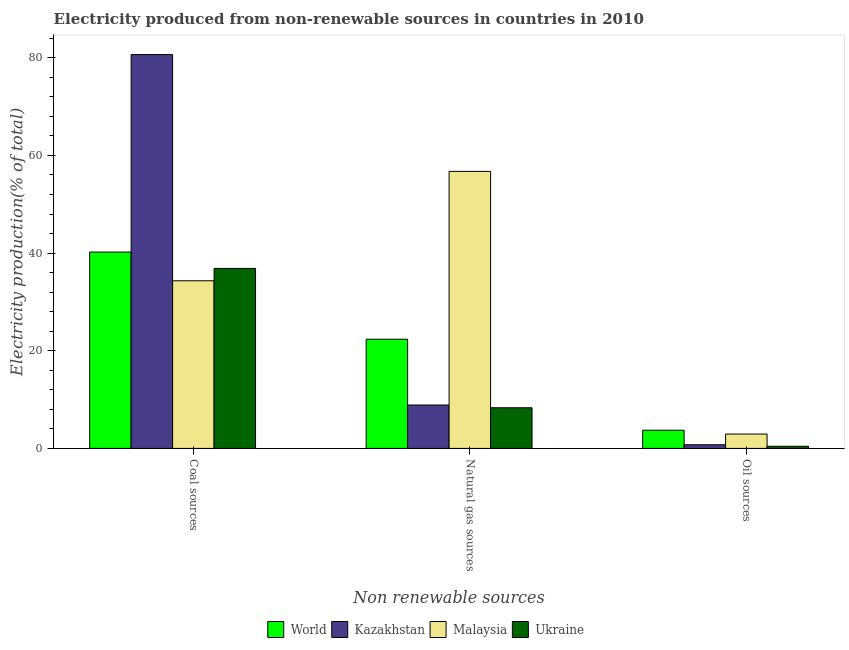How many bars are there on the 3rd tick from the right?
Your response must be concise. 4. What is the label of the 2nd group of bars from the left?
Ensure brevity in your answer.  Natural gas sources. What is the percentage of electricity produced by oil sources in Malaysia?
Provide a succinct answer. 2.94. Across all countries, what is the maximum percentage of electricity produced by natural gas?
Your response must be concise. 56.73. Across all countries, what is the minimum percentage of electricity produced by natural gas?
Offer a very short reply. 8.33. In which country was the percentage of electricity produced by natural gas maximum?
Your response must be concise. Malaysia. In which country was the percentage of electricity produced by natural gas minimum?
Offer a very short reply. Ukraine. What is the total percentage of electricity produced by coal in the graph?
Your answer should be compact. 192.06. What is the difference between the percentage of electricity produced by oil sources in Ukraine and that in Malaysia?
Your answer should be compact. -2.51. What is the difference between the percentage of electricity produced by natural gas in Malaysia and the percentage of electricity produced by coal in World?
Offer a very short reply. 16.52. What is the average percentage of electricity produced by natural gas per country?
Make the answer very short. 24.08. What is the difference between the percentage of electricity produced by oil sources and percentage of electricity produced by natural gas in Malaysia?
Your response must be concise. -53.79. In how many countries, is the percentage of electricity produced by oil sources greater than 36 %?
Make the answer very short. 0. What is the ratio of the percentage of electricity produced by natural gas in Malaysia to that in Ukraine?
Keep it short and to the point. 6.81. What is the difference between the highest and the second highest percentage of electricity produced by oil sources?
Your answer should be compact. 0.79. What is the difference between the highest and the lowest percentage of electricity produced by oil sources?
Your response must be concise. 3.29. Is the sum of the percentage of electricity produced by coal in World and Ukraine greater than the maximum percentage of electricity produced by natural gas across all countries?
Provide a short and direct response. Yes. What does the 1st bar from the left in Natural gas sources represents?
Provide a short and direct response. World. What does the 1st bar from the right in Natural gas sources represents?
Your answer should be compact. Ukraine. Are all the bars in the graph horizontal?
Offer a terse response. No. How many countries are there in the graph?
Your response must be concise. 4. What is the difference between two consecutive major ticks on the Y-axis?
Offer a very short reply. 20. Does the graph contain grids?
Your answer should be compact. No. Where does the legend appear in the graph?
Provide a succinct answer. Bottom center. How are the legend labels stacked?
Make the answer very short. Horizontal. What is the title of the graph?
Your answer should be very brief. Electricity produced from non-renewable sources in countries in 2010. What is the label or title of the X-axis?
Offer a very short reply. Non renewable sources. What is the Electricity production(% of total) of World in Coal sources?
Make the answer very short. 40.21. What is the Electricity production(% of total) of Kazakhstan in Coal sources?
Offer a terse response. 80.65. What is the Electricity production(% of total) of Malaysia in Coal sources?
Give a very brief answer. 34.33. What is the Electricity production(% of total) in Ukraine in Coal sources?
Your response must be concise. 36.86. What is the Electricity production(% of total) in World in Natural gas sources?
Give a very brief answer. 22.36. What is the Electricity production(% of total) of Kazakhstan in Natural gas sources?
Provide a short and direct response. 8.89. What is the Electricity production(% of total) of Malaysia in Natural gas sources?
Make the answer very short. 56.73. What is the Electricity production(% of total) in Ukraine in Natural gas sources?
Ensure brevity in your answer.  8.33. What is the Electricity production(% of total) of World in Oil sources?
Offer a terse response. 3.73. What is the Electricity production(% of total) of Kazakhstan in Oil sources?
Give a very brief answer. 0.75. What is the Electricity production(% of total) of Malaysia in Oil sources?
Offer a terse response. 2.94. What is the Electricity production(% of total) of Ukraine in Oil sources?
Your response must be concise. 0.44. Across all Non renewable sources, what is the maximum Electricity production(% of total) in World?
Keep it short and to the point. 40.21. Across all Non renewable sources, what is the maximum Electricity production(% of total) of Kazakhstan?
Provide a short and direct response. 80.65. Across all Non renewable sources, what is the maximum Electricity production(% of total) of Malaysia?
Offer a terse response. 56.73. Across all Non renewable sources, what is the maximum Electricity production(% of total) in Ukraine?
Offer a very short reply. 36.86. Across all Non renewable sources, what is the minimum Electricity production(% of total) of World?
Give a very brief answer. 3.73. Across all Non renewable sources, what is the minimum Electricity production(% of total) in Kazakhstan?
Give a very brief answer. 0.75. Across all Non renewable sources, what is the minimum Electricity production(% of total) in Malaysia?
Offer a terse response. 2.94. Across all Non renewable sources, what is the minimum Electricity production(% of total) in Ukraine?
Offer a terse response. 0.44. What is the total Electricity production(% of total) of World in the graph?
Your answer should be compact. 66.3. What is the total Electricity production(% of total) of Kazakhstan in the graph?
Keep it short and to the point. 90.29. What is the total Electricity production(% of total) of Malaysia in the graph?
Offer a very short reply. 94. What is the total Electricity production(% of total) in Ukraine in the graph?
Give a very brief answer. 45.62. What is the difference between the Electricity production(% of total) of World in Coal sources and that in Natural gas sources?
Offer a very short reply. 17.85. What is the difference between the Electricity production(% of total) of Kazakhstan in Coal sources and that in Natural gas sources?
Your response must be concise. 71.76. What is the difference between the Electricity production(% of total) of Malaysia in Coal sources and that in Natural gas sources?
Your response must be concise. -22.4. What is the difference between the Electricity production(% of total) of Ukraine in Coal sources and that in Natural gas sources?
Your response must be concise. 28.54. What is the difference between the Electricity production(% of total) in World in Coal sources and that in Oil sources?
Offer a very short reply. 36.48. What is the difference between the Electricity production(% of total) of Kazakhstan in Coal sources and that in Oil sources?
Your answer should be compact. 79.9. What is the difference between the Electricity production(% of total) in Malaysia in Coal sources and that in Oil sources?
Offer a very short reply. 31.39. What is the difference between the Electricity production(% of total) in Ukraine in Coal sources and that in Oil sources?
Provide a short and direct response. 36.43. What is the difference between the Electricity production(% of total) of World in Natural gas sources and that in Oil sources?
Give a very brief answer. 18.63. What is the difference between the Electricity production(% of total) in Kazakhstan in Natural gas sources and that in Oil sources?
Give a very brief answer. 8.14. What is the difference between the Electricity production(% of total) in Malaysia in Natural gas sources and that in Oil sources?
Give a very brief answer. 53.79. What is the difference between the Electricity production(% of total) in Ukraine in Natural gas sources and that in Oil sources?
Provide a short and direct response. 7.89. What is the difference between the Electricity production(% of total) of World in Coal sources and the Electricity production(% of total) of Kazakhstan in Natural gas sources?
Provide a succinct answer. 31.32. What is the difference between the Electricity production(% of total) of World in Coal sources and the Electricity production(% of total) of Malaysia in Natural gas sources?
Make the answer very short. -16.52. What is the difference between the Electricity production(% of total) of World in Coal sources and the Electricity production(% of total) of Ukraine in Natural gas sources?
Your response must be concise. 31.89. What is the difference between the Electricity production(% of total) in Kazakhstan in Coal sources and the Electricity production(% of total) in Malaysia in Natural gas sources?
Give a very brief answer. 23.92. What is the difference between the Electricity production(% of total) of Kazakhstan in Coal sources and the Electricity production(% of total) of Ukraine in Natural gas sources?
Provide a succinct answer. 72.33. What is the difference between the Electricity production(% of total) in Malaysia in Coal sources and the Electricity production(% of total) in Ukraine in Natural gas sources?
Offer a very short reply. 26. What is the difference between the Electricity production(% of total) of World in Coal sources and the Electricity production(% of total) of Kazakhstan in Oil sources?
Your answer should be very brief. 39.46. What is the difference between the Electricity production(% of total) of World in Coal sources and the Electricity production(% of total) of Malaysia in Oil sources?
Provide a succinct answer. 37.27. What is the difference between the Electricity production(% of total) of World in Coal sources and the Electricity production(% of total) of Ukraine in Oil sources?
Provide a short and direct response. 39.78. What is the difference between the Electricity production(% of total) in Kazakhstan in Coal sources and the Electricity production(% of total) in Malaysia in Oil sources?
Offer a terse response. 77.71. What is the difference between the Electricity production(% of total) of Kazakhstan in Coal sources and the Electricity production(% of total) of Ukraine in Oil sources?
Ensure brevity in your answer.  80.22. What is the difference between the Electricity production(% of total) in Malaysia in Coal sources and the Electricity production(% of total) in Ukraine in Oil sources?
Offer a terse response. 33.89. What is the difference between the Electricity production(% of total) in World in Natural gas sources and the Electricity production(% of total) in Kazakhstan in Oil sources?
Provide a short and direct response. 21.61. What is the difference between the Electricity production(% of total) of World in Natural gas sources and the Electricity production(% of total) of Malaysia in Oil sources?
Make the answer very short. 19.42. What is the difference between the Electricity production(% of total) in World in Natural gas sources and the Electricity production(% of total) in Ukraine in Oil sources?
Provide a succinct answer. 21.93. What is the difference between the Electricity production(% of total) in Kazakhstan in Natural gas sources and the Electricity production(% of total) in Malaysia in Oil sources?
Offer a very short reply. 5.95. What is the difference between the Electricity production(% of total) of Kazakhstan in Natural gas sources and the Electricity production(% of total) of Ukraine in Oil sources?
Ensure brevity in your answer.  8.45. What is the difference between the Electricity production(% of total) of Malaysia in Natural gas sources and the Electricity production(% of total) of Ukraine in Oil sources?
Your answer should be compact. 56.3. What is the average Electricity production(% of total) in World per Non renewable sources?
Ensure brevity in your answer.  22.1. What is the average Electricity production(% of total) of Kazakhstan per Non renewable sources?
Your response must be concise. 30.1. What is the average Electricity production(% of total) in Malaysia per Non renewable sources?
Give a very brief answer. 31.33. What is the average Electricity production(% of total) of Ukraine per Non renewable sources?
Your answer should be very brief. 15.21. What is the difference between the Electricity production(% of total) in World and Electricity production(% of total) in Kazakhstan in Coal sources?
Your answer should be compact. -40.44. What is the difference between the Electricity production(% of total) in World and Electricity production(% of total) in Malaysia in Coal sources?
Keep it short and to the point. 5.88. What is the difference between the Electricity production(% of total) in World and Electricity production(% of total) in Ukraine in Coal sources?
Offer a very short reply. 3.35. What is the difference between the Electricity production(% of total) of Kazakhstan and Electricity production(% of total) of Malaysia in Coal sources?
Your response must be concise. 46.32. What is the difference between the Electricity production(% of total) in Kazakhstan and Electricity production(% of total) in Ukraine in Coal sources?
Provide a short and direct response. 43.79. What is the difference between the Electricity production(% of total) in Malaysia and Electricity production(% of total) in Ukraine in Coal sources?
Your answer should be very brief. -2.53. What is the difference between the Electricity production(% of total) in World and Electricity production(% of total) in Kazakhstan in Natural gas sources?
Your answer should be compact. 13.47. What is the difference between the Electricity production(% of total) of World and Electricity production(% of total) of Malaysia in Natural gas sources?
Provide a short and direct response. -34.37. What is the difference between the Electricity production(% of total) of World and Electricity production(% of total) of Ukraine in Natural gas sources?
Make the answer very short. 14.04. What is the difference between the Electricity production(% of total) in Kazakhstan and Electricity production(% of total) in Malaysia in Natural gas sources?
Keep it short and to the point. -47.84. What is the difference between the Electricity production(% of total) of Kazakhstan and Electricity production(% of total) of Ukraine in Natural gas sources?
Offer a terse response. 0.56. What is the difference between the Electricity production(% of total) of Malaysia and Electricity production(% of total) of Ukraine in Natural gas sources?
Make the answer very short. 48.41. What is the difference between the Electricity production(% of total) of World and Electricity production(% of total) of Kazakhstan in Oil sources?
Your answer should be compact. 2.98. What is the difference between the Electricity production(% of total) of World and Electricity production(% of total) of Malaysia in Oil sources?
Your answer should be compact. 0.79. What is the difference between the Electricity production(% of total) in World and Electricity production(% of total) in Ukraine in Oil sources?
Keep it short and to the point. 3.29. What is the difference between the Electricity production(% of total) of Kazakhstan and Electricity production(% of total) of Malaysia in Oil sources?
Ensure brevity in your answer.  -2.19. What is the difference between the Electricity production(% of total) in Kazakhstan and Electricity production(% of total) in Ukraine in Oil sources?
Ensure brevity in your answer.  0.31. What is the difference between the Electricity production(% of total) in Malaysia and Electricity production(% of total) in Ukraine in Oil sources?
Your answer should be compact. 2.51. What is the ratio of the Electricity production(% of total) of World in Coal sources to that in Natural gas sources?
Provide a short and direct response. 1.8. What is the ratio of the Electricity production(% of total) in Kazakhstan in Coal sources to that in Natural gas sources?
Your response must be concise. 9.07. What is the ratio of the Electricity production(% of total) in Malaysia in Coal sources to that in Natural gas sources?
Offer a very short reply. 0.61. What is the ratio of the Electricity production(% of total) in Ukraine in Coal sources to that in Natural gas sources?
Make the answer very short. 4.43. What is the ratio of the Electricity production(% of total) of World in Coal sources to that in Oil sources?
Offer a terse response. 10.79. What is the ratio of the Electricity production(% of total) of Kazakhstan in Coal sources to that in Oil sources?
Ensure brevity in your answer.  107.51. What is the ratio of the Electricity production(% of total) of Malaysia in Coal sources to that in Oil sources?
Ensure brevity in your answer.  11.67. What is the ratio of the Electricity production(% of total) of Ukraine in Coal sources to that in Oil sources?
Your response must be concise. 84.57. What is the ratio of the Electricity production(% of total) in World in Natural gas sources to that in Oil sources?
Make the answer very short. 6. What is the ratio of the Electricity production(% of total) in Kazakhstan in Natural gas sources to that in Oil sources?
Provide a succinct answer. 11.85. What is the ratio of the Electricity production(% of total) of Malaysia in Natural gas sources to that in Oil sources?
Your response must be concise. 19.29. What is the ratio of the Electricity production(% of total) of Ukraine in Natural gas sources to that in Oil sources?
Offer a very short reply. 19.1. What is the difference between the highest and the second highest Electricity production(% of total) of World?
Provide a succinct answer. 17.85. What is the difference between the highest and the second highest Electricity production(% of total) of Kazakhstan?
Your answer should be very brief. 71.76. What is the difference between the highest and the second highest Electricity production(% of total) in Malaysia?
Make the answer very short. 22.4. What is the difference between the highest and the second highest Electricity production(% of total) of Ukraine?
Ensure brevity in your answer.  28.54. What is the difference between the highest and the lowest Electricity production(% of total) of World?
Your answer should be very brief. 36.48. What is the difference between the highest and the lowest Electricity production(% of total) in Kazakhstan?
Your answer should be very brief. 79.9. What is the difference between the highest and the lowest Electricity production(% of total) in Malaysia?
Your answer should be compact. 53.79. What is the difference between the highest and the lowest Electricity production(% of total) in Ukraine?
Give a very brief answer. 36.43. 